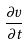Convert formula to latex. <formula><loc_0><loc_0><loc_500><loc_500>\frac { \partial v } { \partial t }</formula> 